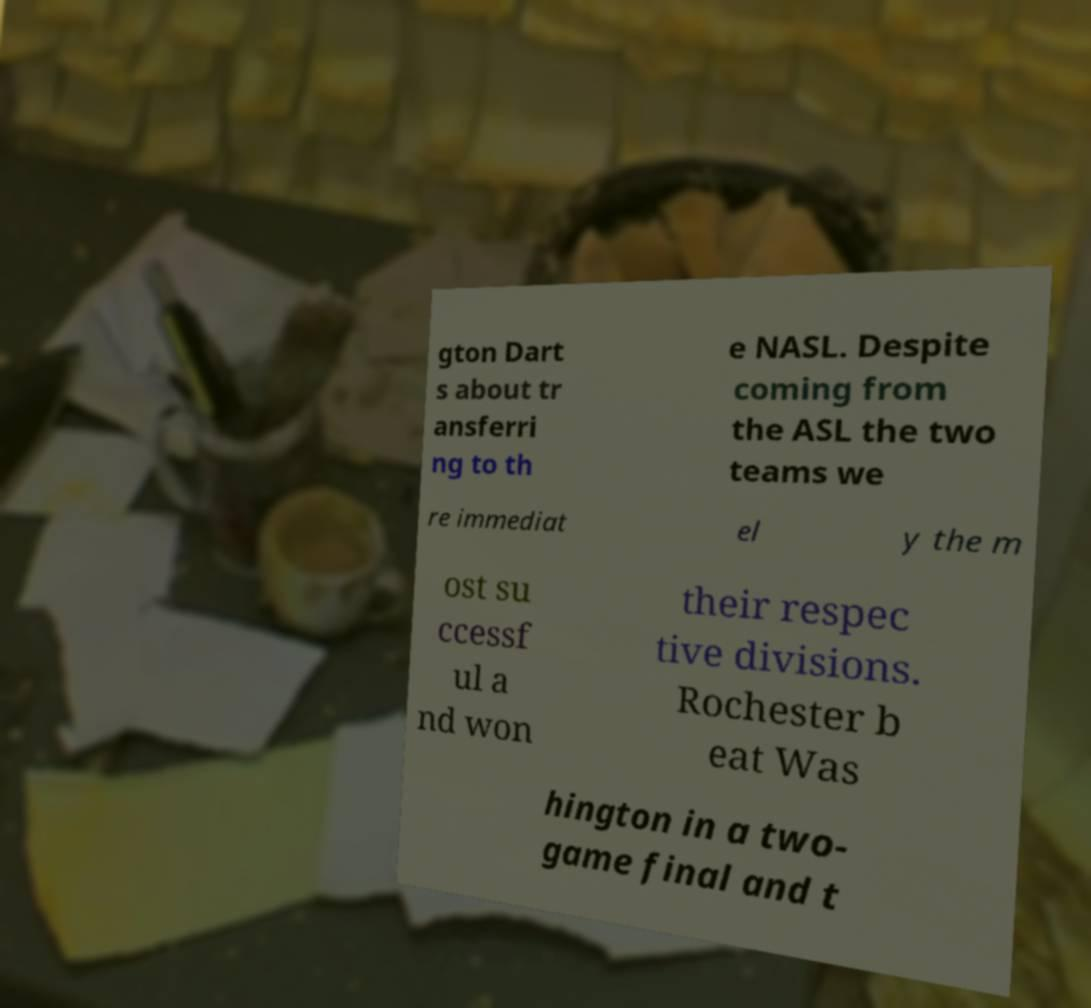For documentation purposes, I need the text within this image transcribed. Could you provide that? gton Dart s about tr ansferri ng to th e NASL. Despite coming from the ASL the two teams we re immediat el y the m ost su ccessf ul a nd won their respec tive divisions. Rochester b eat Was hington in a two- game final and t 